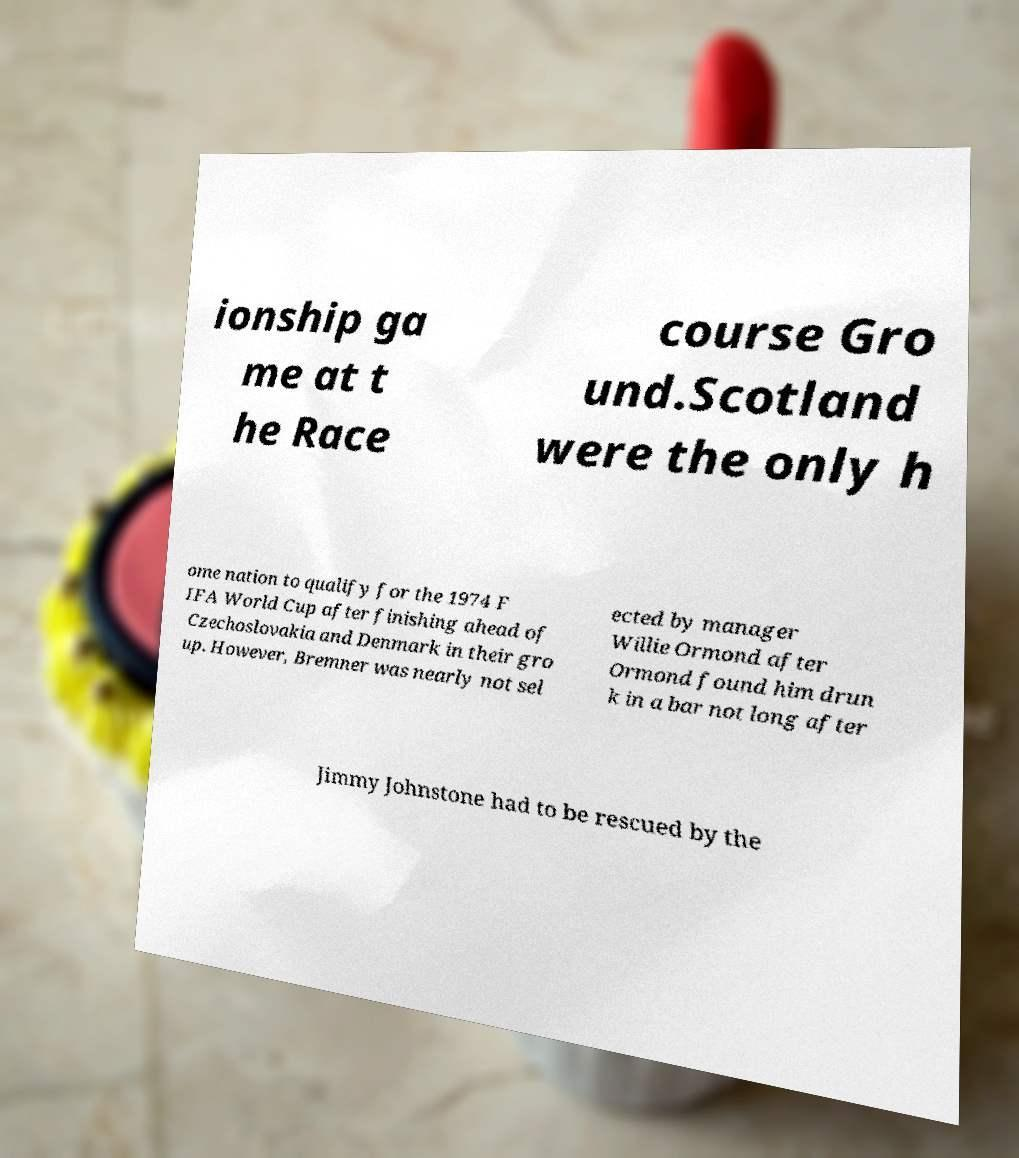Can you read and provide the text displayed in the image?This photo seems to have some interesting text. Can you extract and type it out for me? ionship ga me at t he Race course Gro und.Scotland were the only h ome nation to qualify for the 1974 F IFA World Cup after finishing ahead of Czechoslovakia and Denmark in their gro up. However, Bremner was nearly not sel ected by manager Willie Ormond after Ormond found him drun k in a bar not long after Jimmy Johnstone had to be rescued by the 